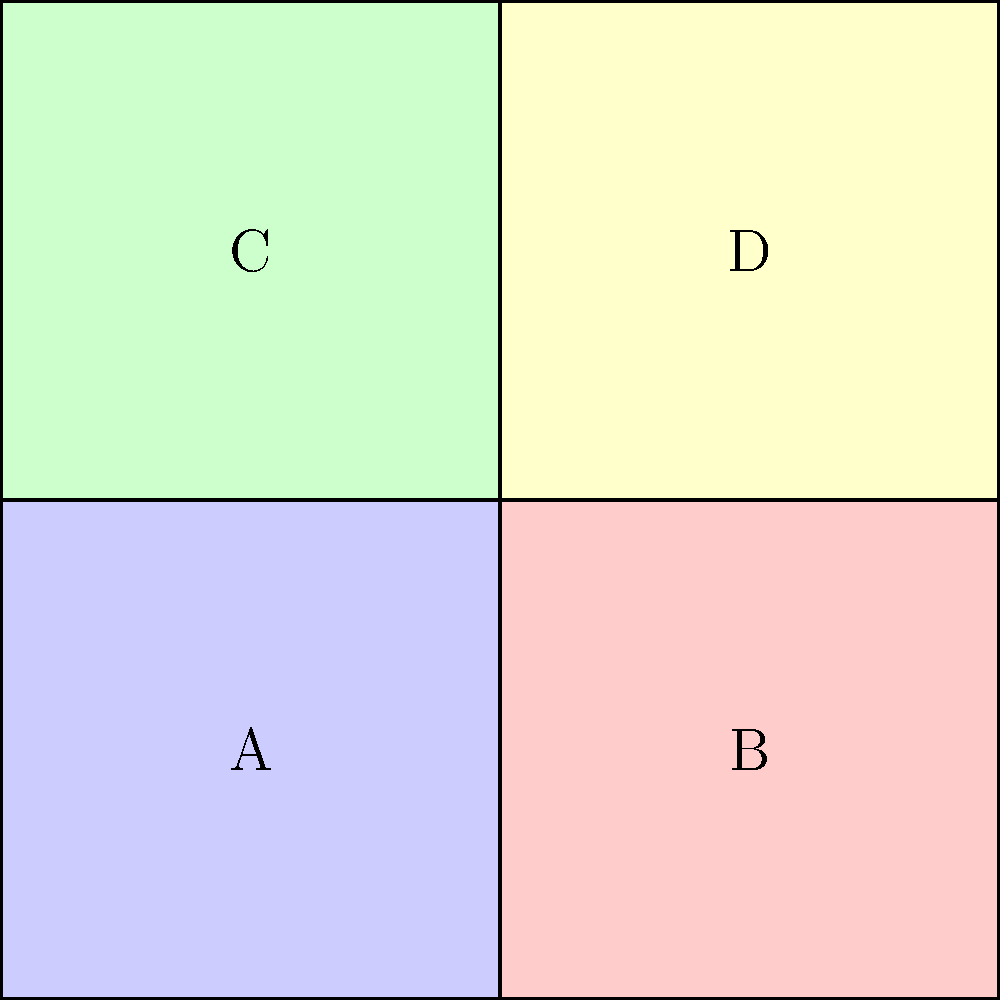Consider the voting district map shown above, where each square represents a distinct district (A, B, C, and D). What is the order of the symmetry group for this map configuration, and how might this impact the fairness of representation in a voting system? To determine the order of the symmetry group for this voting district map, we need to identify all the symmetry operations that leave the overall configuration unchanged:

1. Identity transformation (no change)
2. 180-degree rotation around the center point
3. Reflection across the vertical axis
4. Reflection across the horizontal axis

These four operations form the symmetry group of the map. Let's analyze each step:

1. The identity transformation always exists for any configuration.
2. A 180-degree rotation swaps A with D, and B with C, preserving the overall structure.
3. Reflection across the vertical axis swaps A with B, and C with D.
4. Reflection across the horizontal axis swaps A with C, and B with D.

The order of a group is the number of elements in the group. In this case, we have identified 4 distinct symmetry operations, so the order of the symmetry group is 4.

Impact on fairness of representation:

1. Balanced distribution: The high degree of symmetry suggests a balanced distribution of districts, which could promote fair representation.

2. Gerrymandering concerns: The symmetrical nature makes it harder to gerrymander districts for political advantage, as any manipulation would be more noticeable.

3. Demographic considerations: The symmetry might not account for natural demographic distributions, potentially leading to equal-sized but not necessarily equally representative districts.

4. Compactness: The symmetrical, compact shape of districts can promote community cohesion within each district.

5. Adaptability: The rigid symmetry might make it challenging to adapt the map to population changes over time while maintaining fair representation.

In summary, while the high degree of symmetry can promote certain aspects of fairness, it may also present challenges in adapting to complex demographic realities and changes over time.
Answer: Order 4; promotes balance but may lack demographic adaptability 